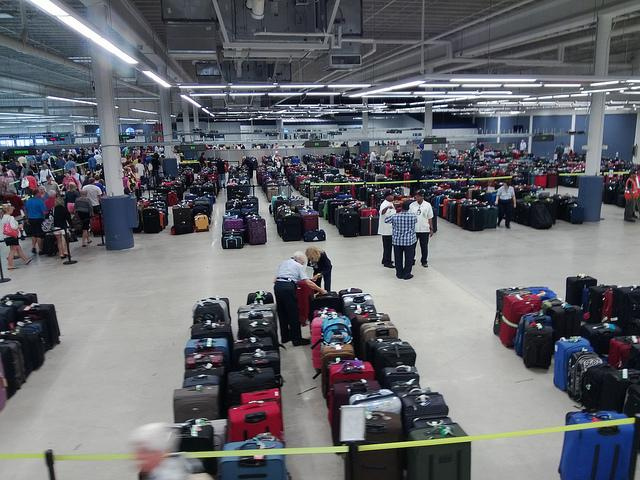What color is the tape fence around the luggage area where there is a number of luggage bags?

Choices:
A) black
B) yellow
C) red
D) white yellow 